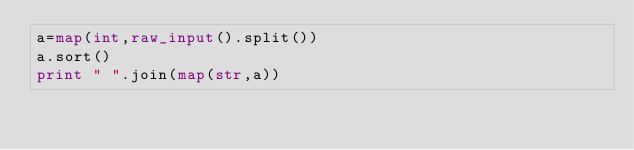<code> <loc_0><loc_0><loc_500><loc_500><_Python_>a=map(int,raw_input().split())
a.sort()
print " ".join(map(str,a))</code> 